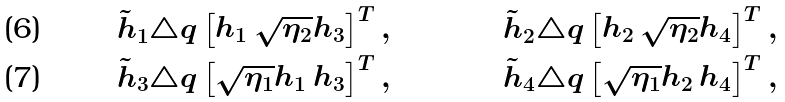Convert formula to latex. <formula><loc_0><loc_0><loc_500><loc_500>\tilde { h } _ { 1 } & \triangle q \begin{bmatrix} h _ { 1 } \, \sqrt { \eta _ { 2 } } h _ { 3 } \end{bmatrix} ^ { T } , & \tilde { h } _ { 2 } & \triangle q \begin{bmatrix} h _ { 2 } \, \sqrt { \eta _ { 2 } } h _ { 4 } \end{bmatrix} ^ { T } , \\ \tilde { h } _ { 3 } & \triangle q \begin{bmatrix} \sqrt { \eta _ { 1 } } h _ { 1 } \, h _ { 3 } \end{bmatrix} ^ { T } , & \tilde { h } _ { 4 } & \triangle q \begin{bmatrix} \sqrt { \eta _ { 1 } } h _ { 2 } \, h _ { 4 } \end{bmatrix} ^ { T } ,</formula> 